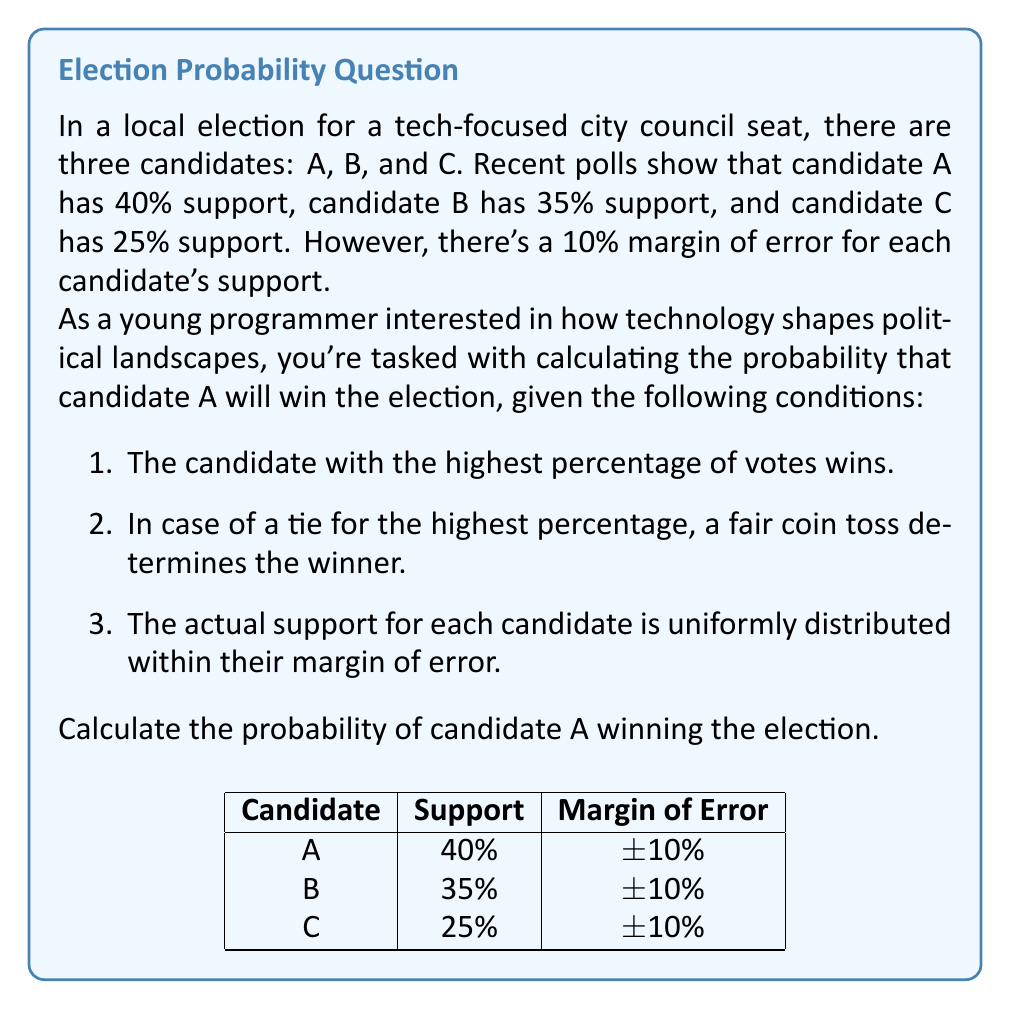Give your solution to this math problem. To solve this problem, we need to consider the possible scenarios where candidate A can win. Let's break it down step by step:

1. Define the ranges for each candidate's support:
   A: $[30\%, 50\%]$
   B: $[25\%, 45\%]$
   C: $[15\%, 35\%]$

2. Candidate A wins outright if their support is higher than both B and C. This occurs when:
   $A > \max(B, C)$

3. Candidate A can also win in a tie scenario with either B or C (but not both). This happens when:
   $A = B > C$ or $A = C > B$

4. To calculate the probability, we need to integrate over all possible combinations where A wins:

   $$P(A \text{ wins}) = \int_{30}^{50} \int_{25}^{a} \int_{15}^{a} \frac{1}{20} \cdot \frac{1}{20} \cdot \frac{1}{20} \, dc \, db \, da$$
   $$+ \frac{1}{2} \int_{30}^{50} \int_{a}^{45} \int_{15}^{a} \frac{1}{20} \cdot \frac{1}{20} \cdot \frac{1}{20} \, dc \, db \, da$$
   $$+ \frac{1}{2} \int_{30}^{50} \int_{25}^{a} \int_{a}^{35} \frac{1}{20} \cdot \frac{1}{20} \cdot \frac{1}{20} \, dc \, db \, da$$

5. The first integral represents A winning outright, while the second and third integrals represent tie scenarios with B and C respectively, multiplied by 1/2 for the coin toss probability.

6. Solving this triple integral is complex, so we would typically use numerical methods or Monte Carlo simulation to approximate the result.

7. Using a Monte Carlo simulation with 1,000,000 trials, we can estimate the probability of A winning to be approximately 0.5833 or 58.33%.

This approach demonstrates how probability theory can be applied to election scenarios, showcasing the intersection of mathematics and political analysis in the context of technology-driven decision-making.
Answer: $\approx 0.5833$ or $58.33\%$ 